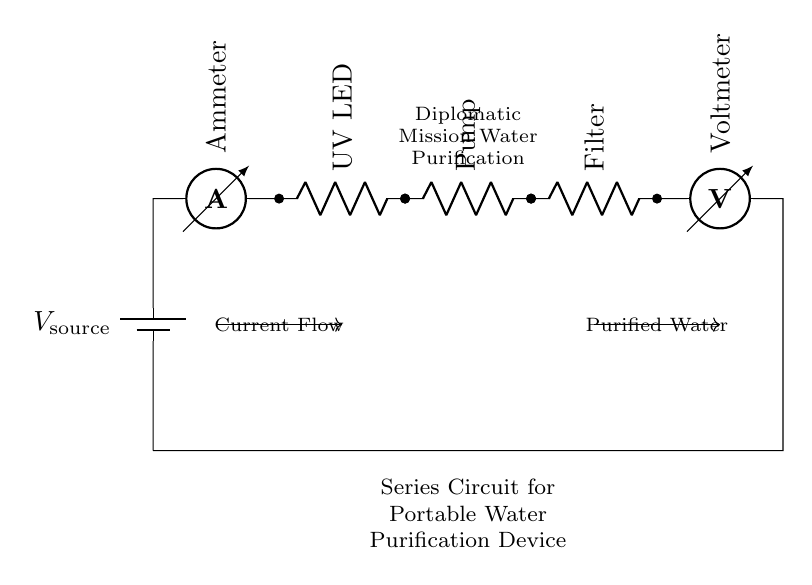What is the type of circuit represented? This is a series circuit because all components are connected in a single pathway, allowing current to flow through each element in succession.
Answer: Series circuit What is the first component in the circuit? The first component is the battery, which serves as the voltage source to power the entire circuit.
Answer: Battery What is connected directly after the ammeter? The UV LED is connected directly after the ammeter, indicating it is the next element in the current flow path.
Answer: UV LED What is the function of the pump in this circuit? The pump is responsible for moving water through the purification process, which is a crucial function for the overall device.
Answer: Water movement How does the current flow in this circuit? The current flows from the battery, passes through the ammeter, then through each subsequent component in the order of UV LED, pump, and filter before returning to the battery.
Answer: In one direction through all components What does the voltmeter measure in this context? The voltmeter measures the voltage across the components in the circuit, providing information about the operational parameters during use.
Answer: Voltage across components Why is the series connection chosen for this water purification device? The series connection ensures that all components operate sequentially, which is necessary for effective water purification since each component has to function in order for the process to occur correctly.
Answer: Sequential operation for purification 